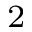Convert formula to latex. <formula><loc_0><loc_0><loc_500><loc_500>_ { 2 }</formula> 